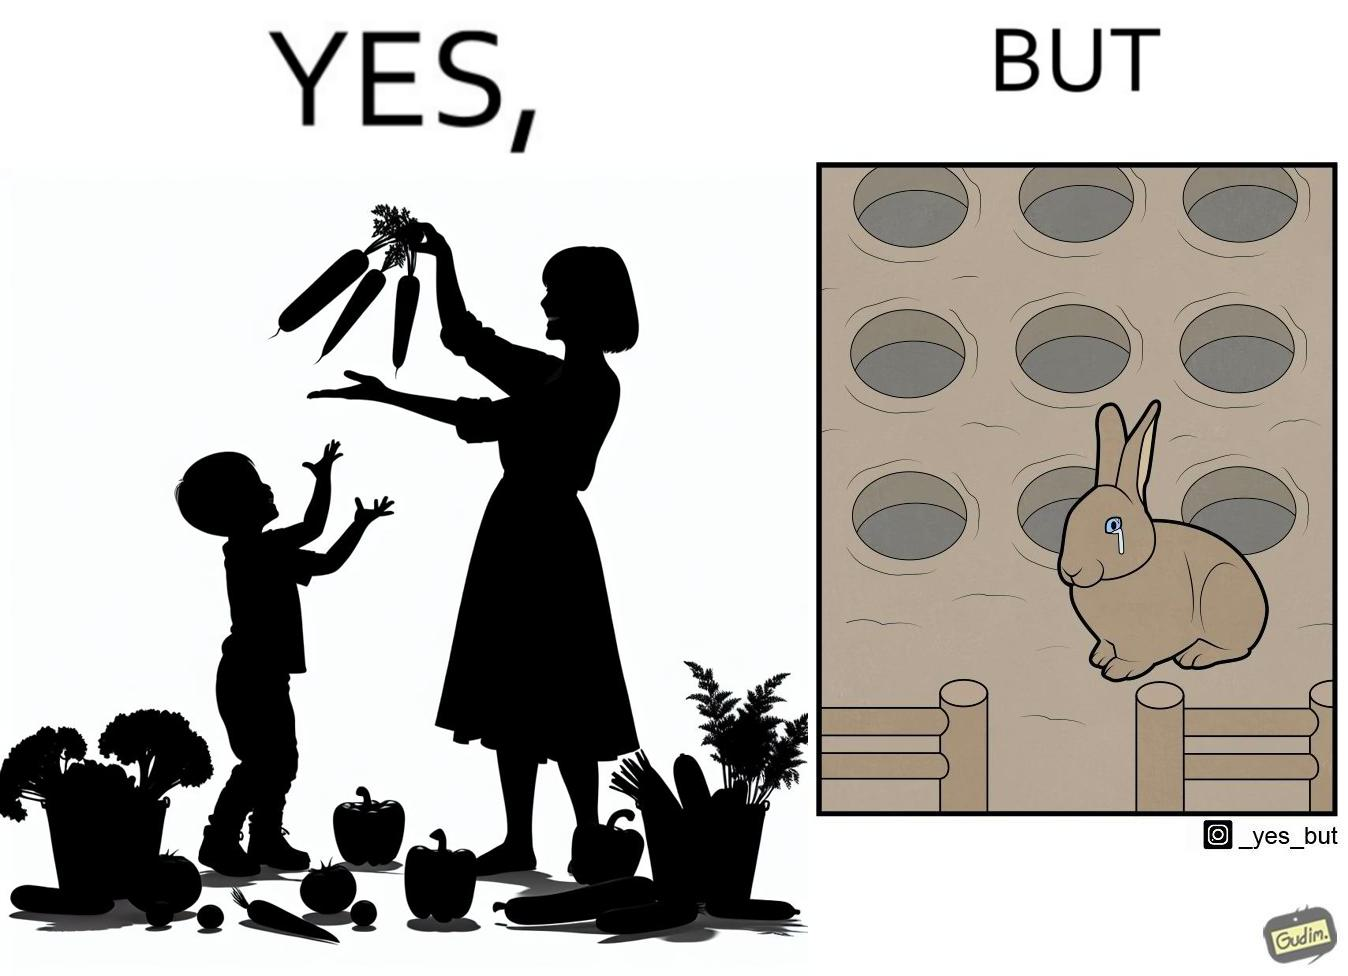Would you classify this image as satirical? Yes, this image is satirical. 